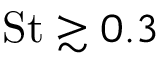Convert formula to latex. <formula><loc_0><loc_0><loc_500><loc_500>S t \gtrsim 0 . 3</formula> 